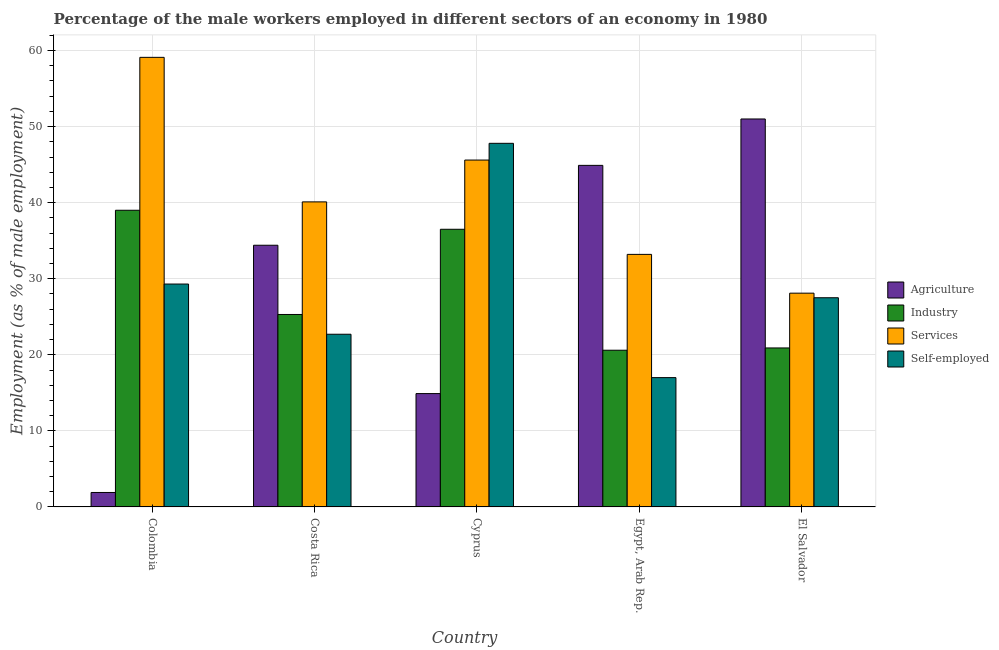How many groups of bars are there?
Provide a short and direct response. 5. Are the number of bars per tick equal to the number of legend labels?
Give a very brief answer. Yes. How many bars are there on the 2nd tick from the left?
Provide a short and direct response. 4. How many bars are there on the 3rd tick from the right?
Your response must be concise. 4. What is the label of the 2nd group of bars from the left?
Offer a very short reply. Costa Rica. In how many cases, is the number of bars for a given country not equal to the number of legend labels?
Ensure brevity in your answer.  0. Across all countries, what is the maximum percentage of self employed male workers?
Provide a succinct answer. 47.8. Across all countries, what is the minimum percentage of male workers in agriculture?
Ensure brevity in your answer.  1.9. In which country was the percentage of male workers in industry maximum?
Your response must be concise. Colombia. In which country was the percentage of male workers in industry minimum?
Offer a terse response. Egypt, Arab Rep. What is the total percentage of self employed male workers in the graph?
Ensure brevity in your answer.  144.3. What is the difference between the percentage of self employed male workers in Colombia and that in El Salvador?
Your answer should be very brief. 1.8. What is the difference between the percentage of self employed male workers in Costa Rica and the percentage of male workers in agriculture in Egypt, Arab Rep.?
Your answer should be compact. -22.2. What is the average percentage of male workers in industry per country?
Your answer should be compact. 28.46. What is the difference between the percentage of male workers in industry and percentage of male workers in agriculture in Colombia?
Offer a terse response. 37.1. In how many countries, is the percentage of male workers in services greater than 48 %?
Keep it short and to the point. 1. What is the ratio of the percentage of self employed male workers in Cyprus to that in Egypt, Arab Rep.?
Provide a succinct answer. 2.81. What is the difference between the highest and the second highest percentage of self employed male workers?
Provide a succinct answer. 18.5. What is the difference between the highest and the lowest percentage of self employed male workers?
Provide a succinct answer. 30.8. In how many countries, is the percentage of male workers in services greater than the average percentage of male workers in services taken over all countries?
Ensure brevity in your answer.  2. Is the sum of the percentage of male workers in industry in Costa Rica and Cyprus greater than the maximum percentage of male workers in services across all countries?
Provide a succinct answer. Yes. What does the 2nd bar from the left in El Salvador represents?
Give a very brief answer. Industry. What does the 2nd bar from the right in Colombia represents?
Offer a very short reply. Services. Is it the case that in every country, the sum of the percentage of male workers in agriculture and percentage of male workers in industry is greater than the percentage of male workers in services?
Your answer should be very brief. No. How many bars are there?
Your answer should be compact. 20. Are all the bars in the graph horizontal?
Your answer should be very brief. No. How many countries are there in the graph?
Offer a terse response. 5. What is the difference between two consecutive major ticks on the Y-axis?
Provide a short and direct response. 10. Does the graph contain any zero values?
Your answer should be compact. No. How many legend labels are there?
Offer a terse response. 4. How are the legend labels stacked?
Make the answer very short. Vertical. What is the title of the graph?
Provide a short and direct response. Percentage of the male workers employed in different sectors of an economy in 1980. What is the label or title of the X-axis?
Provide a succinct answer. Country. What is the label or title of the Y-axis?
Make the answer very short. Employment (as % of male employment). What is the Employment (as % of male employment) in Agriculture in Colombia?
Provide a succinct answer. 1.9. What is the Employment (as % of male employment) in Industry in Colombia?
Your response must be concise. 39. What is the Employment (as % of male employment) of Services in Colombia?
Make the answer very short. 59.1. What is the Employment (as % of male employment) of Self-employed in Colombia?
Your answer should be very brief. 29.3. What is the Employment (as % of male employment) of Agriculture in Costa Rica?
Make the answer very short. 34.4. What is the Employment (as % of male employment) in Industry in Costa Rica?
Your answer should be very brief. 25.3. What is the Employment (as % of male employment) in Services in Costa Rica?
Provide a short and direct response. 40.1. What is the Employment (as % of male employment) in Self-employed in Costa Rica?
Give a very brief answer. 22.7. What is the Employment (as % of male employment) in Agriculture in Cyprus?
Provide a short and direct response. 14.9. What is the Employment (as % of male employment) of Industry in Cyprus?
Provide a succinct answer. 36.5. What is the Employment (as % of male employment) of Services in Cyprus?
Give a very brief answer. 45.6. What is the Employment (as % of male employment) in Self-employed in Cyprus?
Your answer should be compact. 47.8. What is the Employment (as % of male employment) in Agriculture in Egypt, Arab Rep.?
Your answer should be compact. 44.9. What is the Employment (as % of male employment) of Industry in Egypt, Arab Rep.?
Offer a terse response. 20.6. What is the Employment (as % of male employment) in Services in Egypt, Arab Rep.?
Provide a succinct answer. 33.2. What is the Employment (as % of male employment) of Industry in El Salvador?
Your answer should be compact. 20.9. What is the Employment (as % of male employment) in Services in El Salvador?
Provide a succinct answer. 28.1. What is the Employment (as % of male employment) in Self-employed in El Salvador?
Make the answer very short. 27.5. Across all countries, what is the maximum Employment (as % of male employment) of Agriculture?
Keep it short and to the point. 51. Across all countries, what is the maximum Employment (as % of male employment) in Services?
Give a very brief answer. 59.1. Across all countries, what is the maximum Employment (as % of male employment) in Self-employed?
Provide a short and direct response. 47.8. Across all countries, what is the minimum Employment (as % of male employment) in Agriculture?
Offer a very short reply. 1.9. Across all countries, what is the minimum Employment (as % of male employment) of Industry?
Make the answer very short. 20.6. Across all countries, what is the minimum Employment (as % of male employment) in Services?
Give a very brief answer. 28.1. Across all countries, what is the minimum Employment (as % of male employment) in Self-employed?
Make the answer very short. 17. What is the total Employment (as % of male employment) of Agriculture in the graph?
Offer a terse response. 147.1. What is the total Employment (as % of male employment) in Industry in the graph?
Make the answer very short. 142.3. What is the total Employment (as % of male employment) in Services in the graph?
Ensure brevity in your answer.  206.1. What is the total Employment (as % of male employment) of Self-employed in the graph?
Give a very brief answer. 144.3. What is the difference between the Employment (as % of male employment) of Agriculture in Colombia and that in Costa Rica?
Your answer should be compact. -32.5. What is the difference between the Employment (as % of male employment) of Industry in Colombia and that in Costa Rica?
Provide a succinct answer. 13.7. What is the difference between the Employment (as % of male employment) of Services in Colombia and that in Costa Rica?
Offer a very short reply. 19. What is the difference between the Employment (as % of male employment) of Self-employed in Colombia and that in Costa Rica?
Provide a short and direct response. 6.6. What is the difference between the Employment (as % of male employment) of Agriculture in Colombia and that in Cyprus?
Your response must be concise. -13. What is the difference between the Employment (as % of male employment) in Industry in Colombia and that in Cyprus?
Ensure brevity in your answer.  2.5. What is the difference between the Employment (as % of male employment) in Services in Colombia and that in Cyprus?
Ensure brevity in your answer.  13.5. What is the difference between the Employment (as % of male employment) of Self-employed in Colombia and that in Cyprus?
Provide a succinct answer. -18.5. What is the difference between the Employment (as % of male employment) of Agriculture in Colombia and that in Egypt, Arab Rep.?
Offer a terse response. -43. What is the difference between the Employment (as % of male employment) of Services in Colombia and that in Egypt, Arab Rep.?
Give a very brief answer. 25.9. What is the difference between the Employment (as % of male employment) of Agriculture in Colombia and that in El Salvador?
Keep it short and to the point. -49.1. What is the difference between the Employment (as % of male employment) of Industry in Colombia and that in El Salvador?
Offer a terse response. 18.1. What is the difference between the Employment (as % of male employment) in Services in Colombia and that in El Salvador?
Provide a short and direct response. 31. What is the difference between the Employment (as % of male employment) in Industry in Costa Rica and that in Cyprus?
Make the answer very short. -11.2. What is the difference between the Employment (as % of male employment) in Self-employed in Costa Rica and that in Cyprus?
Provide a succinct answer. -25.1. What is the difference between the Employment (as % of male employment) of Agriculture in Costa Rica and that in Egypt, Arab Rep.?
Give a very brief answer. -10.5. What is the difference between the Employment (as % of male employment) in Industry in Costa Rica and that in Egypt, Arab Rep.?
Your response must be concise. 4.7. What is the difference between the Employment (as % of male employment) in Agriculture in Costa Rica and that in El Salvador?
Offer a terse response. -16.6. What is the difference between the Employment (as % of male employment) of Services in Costa Rica and that in El Salvador?
Your answer should be compact. 12. What is the difference between the Employment (as % of male employment) of Agriculture in Cyprus and that in Egypt, Arab Rep.?
Offer a very short reply. -30. What is the difference between the Employment (as % of male employment) of Services in Cyprus and that in Egypt, Arab Rep.?
Ensure brevity in your answer.  12.4. What is the difference between the Employment (as % of male employment) in Self-employed in Cyprus and that in Egypt, Arab Rep.?
Your answer should be very brief. 30.8. What is the difference between the Employment (as % of male employment) in Agriculture in Cyprus and that in El Salvador?
Make the answer very short. -36.1. What is the difference between the Employment (as % of male employment) in Industry in Cyprus and that in El Salvador?
Ensure brevity in your answer.  15.6. What is the difference between the Employment (as % of male employment) in Services in Cyprus and that in El Salvador?
Ensure brevity in your answer.  17.5. What is the difference between the Employment (as % of male employment) of Self-employed in Cyprus and that in El Salvador?
Keep it short and to the point. 20.3. What is the difference between the Employment (as % of male employment) of Agriculture in Egypt, Arab Rep. and that in El Salvador?
Give a very brief answer. -6.1. What is the difference between the Employment (as % of male employment) in Self-employed in Egypt, Arab Rep. and that in El Salvador?
Your response must be concise. -10.5. What is the difference between the Employment (as % of male employment) in Agriculture in Colombia and the Employment (as % of male employment) in Industry in Costa Rica?
Provide a short and direct response. -23.4. What is the difference between the Employment (as % of male employment) in Agriculture in Colombia and the Employment (as % of male employment) in Services in Costa Rica?
Offer a terse response. -38.2. What is the difference between the Employment (as % of male employment) of Agriculture in Colombia and the Employment (as % of male employment) of Self-employed in Costa Rica?
Give a very brief answer. -20.8. What is the difference between the Employment (as % of male employment) of Services in Colombia and the Employment (as % of male employment) of Self-employed in Costa Rica?
Ensure brevity in your answer.  36.4. What is the difference between the Employment (as % of male employment) of Agriculture in Colombia and the Employment (as % of male employment) of Industry in Cyprus?
Offer a terse response. -34.6. What is the difference between the Employment (as % of male employment) of Agriculture in Colombia and the Employment (as % of male employment) of Services in Cyprus?
Make the answer very short. -43.7. What is the difference between the Employment (as % of male employment) in Agriculture in Colombia and the Employment (as % of male employment) in Self-employed in Cyprus?
Your answer should be very brief. -45.9. What is the difference between the Employment (as % of male employment) of Industry in Colombia and the Employment (as % of male employment) of Self-employed in Cyprus?
Offer a very short reply. -8.8. What is the difference between the Employment (as % of male employment) in Services in Colombia and the Employment (as % of male employment) in Self-employed in Cyprus?
Keep it short and to the point. 11.3. What is the difference between the Employment (as % of male employment) in Agriculture in Colombia and the Employment (as % of male employment) in Industry in Egypt, Arab Rep.?
Ensure brevity in your answer.  -18.7. What is the difference between the Employment (as % of male employment) of Agriculture in Colombia and the Employment (as % of male employment) of Services in Egypt, Arab Rep.?
Offer a very short reply. -31.3. What is the difference between the Employment (as % of male employment) of Agriculture in Colombia and the Employment (as % of male employment) of Self-employed in Egypt, Arab Rep.?
Give a very brief answer. -15.1. What is the difference between the Employment (as % of male employment) in Services in Colombia and the Employment (as % of male employment) in Self-employed in Egypt, Arab Rep.?
Keep it short and to the point. 42.1. What is the difference between the Employment (as % of male employment) of Agriculture in Colombia and the Employment (as % of male employment) of Industry in El Salvador?
Your answer should be compact. -19. What is the difference between the Employment (as % of male employment) in Agriculture in Colombia and the Employment (as % of male employment) in Services in El Salvador?
Ensure brevity in your answer.  -26.2. What is the difference between the Employment (as % of male employment) of Agriculture in Colombia and the Employment (as % of male employment) of Self-employed in El Salvador?
Your answer should be compact. -25.6. What is the difference between the Employment (as % of male employment) of Services in Colombia and the Employment (as % of male employment) of Self-employed in El Salvador?
Give a very brief answer. 31.6. What is the difference between the Employment (as % of male employment) in Agriculture in Costa Rica and the Employment (as % of male employment) in Industry in Cyprus?
Your answer should be very brief. -2.1. What is the difference between the Employment (as % of male employment) of Agriculture in Costa Rica and the Employment (as % of male employment) of Self-employed in Cyprus?
Your response must be concise. -13.4. What is the difference between the Employment (as % of male employment) of Industry in Costa Rica and the Employment (as % of male employment) of Services in Cyprus?
Offer a very short reply. -20.3. What is the difference between the Employment (as % of male employment) of Industry in Costa Rica and the Employment (as % of male employment) of Self-employed in Cyprus?
Make the answer very short. -22.5. What is the difference between the Employment (as % of male employment) of Industry in Costa Rica and the Employment (as % of male employment) of Self-employed in Egypt, Arab Rep.?
Your answer should be compact. 8.3. What is the difference between the Employment (as % of male employment) in Services in Costa Rica and the Employment (as % of male employment) in Self-employed in Egypt, Arab Rep.?
Keep it short and to the point. 23.1. What is the difference between the Employment (as % of male employment) in Agriculture in Costa Rica and the Employment (as % of male employment) in Industry in El Salvador?
Make the answer very short. 13.5. What is the difference between the Employment (as % of male employment) of Industry in Costa Rica and the Employment (as % of male employment) of Self-employed in El Salvador?
Ensure brevity in your answer.  -2.2. What is the difference between the Employment (as % of male employment) in Agriculture in Cyprus and the Employment (as % of male employment) in Services in Egypt, Arab Rep.?
Give a very brief answer. -18.3. What is the difference between the Employment (as % of male employment) of Agriculture in Cyprus and the Employment (as % of male employment) of Self-employed in Egypt, Arab Rep.?
Offer a terse response. -2.1. What is the difference between the Employment (as % of male employment) in Industry in Cyprus and the Employment (as % of male employment) in Self-employed in Egypt, Arab Rep.?
Ensure brevity in your answer.  19.5. What is the difference between the Employment (as % of male employment) of Services in Cyprus and the Employment (as % of male employment) of Self-employed in Egypt, Arab Rep.?
Give a very brief answer. 28.6. What is the difference between the Employment (as % of male employment) in Agriculture in Cyprus and the Employment (as % of male employment) in Industry in El Salvador?
Offer a very short reply. -6. What is the difference between the Employment (as % of male employment) of Agriculture in Cyprus and the Employment (as % of male employment) of Services in El Salvador?
Provide a succinct answer. -13.2. What is the difference between the Employment (as % of male employment) of Agriculture in Cyprus and the Employment (as % of male employment) of Self-employed in El Salvador?
Your answer should be compact. -12.6. What is the difference between the Employment (as % of male employment) in Industry in Cyprus and the Employment (as % of male employment) in Services in El Salvador?
Keep it short and to the point. 8.4. What is the difference between the Employment (as % of male employment) of Agriculture in Egypt, Arab Rep. and the Employment (as % of male employment) of Industry in El Salvador?
Offer a terse response. 24. What is the difference between the Employment (as % of male employment) in Industry in Egypt, Arab Rep. and the Employment (as % of male employment) in Services in El Salvador?
Ensure brevity in your answer.  -7.5. What is the difference between the Employment (as % of male employment) in Industry in Egypt, Arab Rep. and the Employment (as % of male employment) in Self-employed in El Salvador?
Keep it short and to the point. -6.9. What is the difference between the Employment (as % of male employment) in Services in Egypt, Arab Rep. and the Employment (as % of male employment) in Self-employed in El Salvador?
Your answer should be compact. 5.7. What is the average Employment (as % of male employment) in Agriculture per country?
Keep it short and to the point. 29.42. What is the average Employment (as % of male employment) in Industry per country?
Your answer should be compact. 28.46. What is the average Employment (as % of male employment) of Services per country?
Keep it short and to the point. 41.22. What is the average Employment (as % of male employment) of Self-employed per country?
Provide a short and direct response. 28.86. What is the difference between the Employment (as % of male employment) in Agriculture and Employment (as % of male employment) in Industry in Colombia?
Offer a very short reply. -37.1. What is the difference between the Employment (as % of male employment) in Agriculture and Employment (as % of male employment) in Services in Colombia?
Keep it short and to the point. -57.2. What is the difference between the Employment (as % of male employment) in Agriculture and Employment (as % of male employment) in Self-employed in Colombia?
Provide a short and direct response. -27.4. What is the difference between the Employment (as % of male employment) of Industry and Employment (as % of male employment) of Services in Colombia?
Your answer should be compact. -20.1. What is the difference between the Employment (as % of male employment) of Services and Employment (as % of male employment) of Self-employed in Colombia?
Provide a succinct answer. 29.8. What is the difference between the Employment (as % of male employment) of Agriculture and Employment (as % of male employment) of Industry in Costa Rica?
Your answer should be compact. 9.1. What is the difference between the Employment (as % of male employment) of Agriculture and Employment (as % of male employment) of Services in Costa Rica?
Keep it short and to the point. -5.7. What is the difference between the Employment (as % of male employment) of Agriculture and Employment (as % of male employment) of Self-employed in Costa Rica?
Make the answer very short. 11.7. What is the difference between the Employment (as % of male employment) in Industry and Employment (as % of male employment) in Services in Costa Rica?
Offer a very short reply. -14.8. What is the difference between the Employment (as % of male employment) in Industry and Employment (as % of male employment) in Self-employed in Costa Rica?
Keep it short and to the point. 2.6. What is the difference between the Employment (as % of male employment) of Agriculture and Employment (as % of male employment) of Industry in Cyprus?
Your answer should be compact. -21.6. What is the difference between the Employment (as % of male employment) in Agriculture and Employment (as % of male employment) in Services in Cyprus?
Keep it short and to the point. -30.7. What is the difference between the Employment (as % of male employment) in Agriculture and Employment (as % of male employment) in Self-employed in Cyprus?
Your answer should be compact. -32.9. What is the difference between the Employment (as % of male employment) in Industry and Employment (as % of male employment) in Services in Cyprus?
Offer a terse response. -9.1. What is the difference between the Employment (as % of male employment) of Industry and Employment (as % of male employment) of Self-employed in Cyprus?
Offer a terse response. -11.3. What is the difference between the Employment (as % of male employment) in Services and Employment (as % of male employment) in Self-employed in Cyprus?
Provide a short and direct response. -2.2. What is the difference between the Employment (as % of male employment) of Agriculture and Employment (as % of male employment) of Industry in Egypt, Arab Rep.?
Keep it short and to the point. 24.3. What is the difference between the Employment (as % of male employment) of Agriculture and Employment (as % of male employment) of Services in Egypt, Arab Rep.?
Give a very brief answer. 11.7. What is the difference between the Employment (as % of male employment) of Agriculture and Employment (as % of male employment) of Self-employed in Egypt, Arab Rep.?
Make the answer very short. 27.9. What is the difference between the Employment (as % of male employment) in Services and Employment (as % of male employment) in Self-employed in Egypt, Arab Rep.?
Provide a short and direct response. 16.2. What is the difference between the Employment (as % of male employment) of Agriculture and Employment (as % of male employment) of Industry in El Salvador?
Your answer should be compact. 30.1. What is the difference between the Employment (as % of male employment) in Agriculture and Employment (as % of male employment) in Services in El Salvador?
Your answer should be compact. 22.9. What is the difference between the Employment (as % of male employment) of Services and Employment (as % of male employment) of Self-employed in El Salvador?
Keep it short and to the point. 0.6. What is the ratio of the Employment (as % of male employment) in Agriculture in Colombia to that in Costa Rica?
Make the answer very short. 0.06. What is the ratio of the Employment (as % of male employment) of Industry in Colombia to that in Costa Rica?
Your answer should be compact. 1.54. What is the ratio of the Employment (as % of male employment) of Services in Colombia to that in Costa Rica?
Make the answer very short. 1.47. What is the ratio of the Employment (as % of male employment) in Self-employed in Colombia to that in Costa Rica?
Keep it short and to the point. 1.29. What is the ratio of the Employment (as % of male employment) in Agriculture in Colombia to that in Cyprus?
Your answer should be compact. 0.13. What is the ratio of the Employment (as % of male employment) in Industry in Colombia to that in Cyprus?
Give a very brief answer. 1.07. What is the ratio of the Employment (as % of male employment) of Services in Colombia to that in Cyprus?
Ensure brevity in your answer.  1.3. What is the ratio of the Employment (as % of male employment) of Self-employed in Colombia to that in Cyprus?
Keep it short and to the point. 0.61. What is the ratio of the Employment (as % of male employment) of Agriculture in Colombia to that in Egypt, Arab Rep.?
Keep it short and to the point. 0.04. What is the ratio of the Employment (as % of male employment) of Industry in Colombia to that in Egypt, Arab Rep.?
Provide a succinct answer. 1.89. What is the ratio of the Employment (as % of male employment) in Services in Colombia to that in Egypt, Arab Rep.?
Your answer should be compact. 1.78. What is the ratio of the Employment (as % of male employment) of Self-employed in Colombia to that in Egypt, Arab Rep.?
Make the answer very short. 1.72. What is the ratio of the Employment (as % of male employment) of Agriculture in Colombia to that in El Salvador?
Ensure brevity in your answer.  0.04. What is the ratio of the Employment (as % of male employment) of Industry in Colombia to that in El Salvador?
Ensure brevity in your answer.  1.87. What is the ratio of the Employment (as % of male employment) of Services in Colombia to that in El Salvador?
Provide a short and direct response. 2.1. What is the ratio of the Employment (as % of male employment) of Self-employed in Colombia to that in El Salvador?
Your answer should be compact. 1.07. What is the ratio of the Employment (as % of male employment) of Agriculture in Costa Rica to that in Cyprus?
Your answer should be very brief. 2.31. What is the ratio of the Employment (as % of male employment) of Industry in Costa Rica to that in Cyprus?
Make the answer very short. 0.69. What is the ratio of the Employment (as % of male employment) of Services in Costa Rica to that in Cyprus?
Your answer should be very brief. 0.88. What is the ratio of the Employment (as % of male employment) of Self-employed in Costa Rica to that in Cyprus?
Your answer should be compact. 0.47. What is the ratio of the Employment (as % of male employment) of Agriculture in Costa Rica to that in Egypt, Arab Rep.?
Give a very brief answer. 0.77. What is the ratio of the Employment (as % of male employment) of Industry in Costa Rica to that in Egypt, Arab Rep.?
Your answer should be very brief. 1.23. What is the ratio of the Employment (as % of male employment) of Services in Costa Rica to that in Egypt, Arab Rep.?
Offer a very short reply. 1.21. What is the ratio of the Employment (as % of male employment) of Self-employed in Costa Rica to that in Egypt, Arab Rep.?
Provide a short and direct response. 1.34. What is the ratio of the Employment (as % of male employment) in Agriculture in Costa Rica to that in El Salvador?
Offer a terse response. 0.67. What is the ratio of the Employment (as % of male employment) in Industry in Costa Rica to that in El Salvador?
Offer a very short reply. 1.21. What is the ratio of the Employment (as % of male employment) of Services in Costa Rica to that in El Salvador?
Give a very brief answer. 1.43. What is the ratio of the Employment (as % of male employment) in Self-employed in Costa Rica to that in El Salvador?
Your response must be concise. 0.83. What is the ratio of the Employment (as % of male employment) in Agriculture in Cyprus to that in Egypt, Arab Rep.?
Provide a succinct answer. 0.33. What is the ratio of the Employment (as % of male employment) in Industry in Cyprus to that in Egypt, Arab Rep.?
Give a very brief answer. 1.77. What is the ratio of the Employment (as % of male employment) in Services in Cyprus to that in Egypt, Arab Rep.?
Your answer should be very brief. 1.37. What is the ratio of the Employment (as % of male employment) of Self-employed in Cyprus to that in Egypt, Arab Rep.?
Make the answer very short. 2.81. What is the ratio of the Employment (as % of male employment) in Agriculture in Cyprus to that in El Salvador?
Your response must be concise. 0.29. What is the ratio of the Employment (as % of male employment) in Industry in Cyprus to that in El Salvador?
Offer a very short reply. 1.75. What is the ratio of the Employment (as % of male employment) of Services in Cyprus to that in El Salvador?
Ensure brevity in your answer.  1.62. What is the ratio of the Employment (as % of male employment) in Self-employed in Cyprus to that in El Salvador?
Offer a terse response. 1.74. What is the ratio of the Employment (as % of male employment) in Agriculture in Egypt, Arab Rep. to that in El Salvador?
Offer a very short reply. 0.88. What is the ratio of the Employment (as % of male employment) in Industry in Egypt, Arab Rep. to that in El Salvador?
Give a very brief answer. 0.99. What is the ratio of the Employment (as % of male employment) of Services in Egypt, Arab Rep. to that in El Salvador?
Provide a short and direct response. 1.18. What is the ratio of the Employment (as % of male employment) in Self-employed in Egypt, Arab Rep. to that in El Salvador?
Provide a succinct answer. 0.62. What is the difference between the highest and the lowest Employment (as % of male employment) of Agriculture?
Keep it short and to the point. 49.1. What is the difference between the highest and the lowest Employment (as % of male employment) of Services?
Offer a terse response. 31. What is the difference between the highest and the lowest Employment (as % of male employment) in Self-employed?
Give a very brief answer. 30.8. 